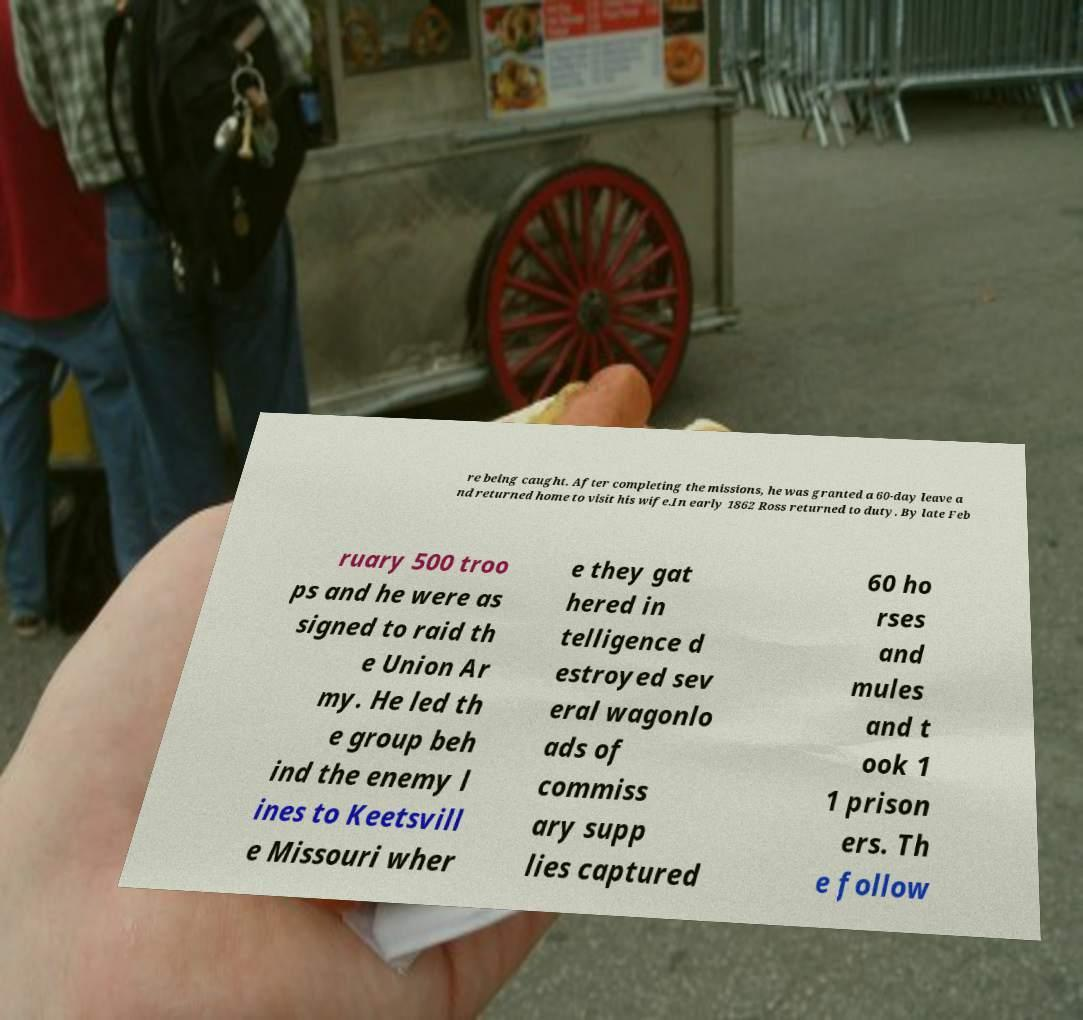What messages or text are displayed in this image? I need them in a readable, typed format. re being caught. After completing the missions, he was granted a 60-day leave a nd returned home to visit his wife.In early 1862 Ross returned to duty. By late Feb ruary 500 troo ps and he were as signed to raid th e Union Ar my. He led th e group beh ind the enemy l ines to Keetsvill e Missouri wher e they gat hered in telligence d estroyed sev eral wagonlo ads of commiss ary supp lies captured 60 ho rses and mules and t ook 1 1 prison ers. Th e follow 